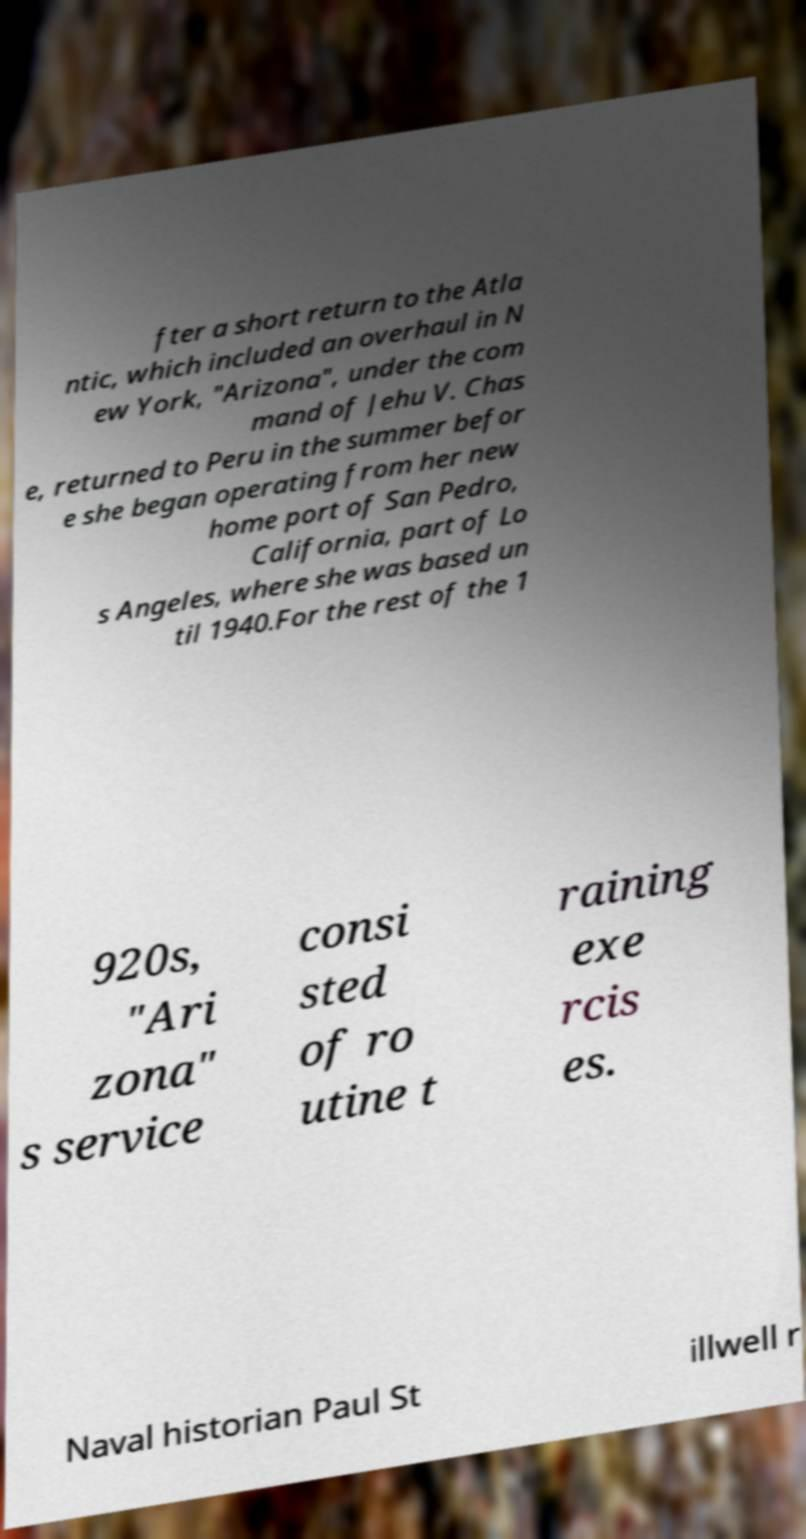For documentation purposes, I need the text within this image transcribed. Could you provide that? fter a short return to the Atla ntic, which included an overhaul in N ew York, "Arizona", under the com mand of Jehu V. Chas e, returned to Peru in the summer befor e she began operating from her new home port of San Pedro, California, part of Lo s Angeles, where she was based un til 1940.For the rest of the 1 920s, "Ari zona" s service consi sted of ro utine t raining exe rcis es. Naval historian Paul St illwell r 